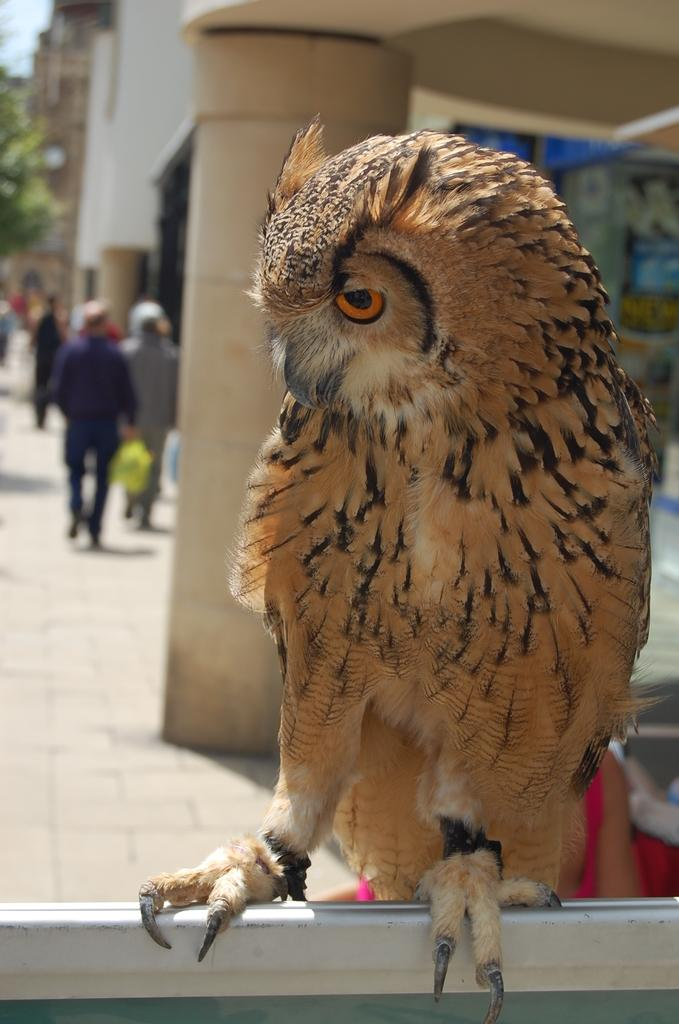What animal is on a metal rod in the image? There is an owl on a metal rod in the image. What can be seen in the background of the image? There are people walking on a pathway, buildings, and trees visible in the background of the image. Where is the wrench being used in the image? There is no wrench present in the image. How many bees are buzzing around the owl in the image? There are no bees present in the image; it only features an owl on a metal rod. 